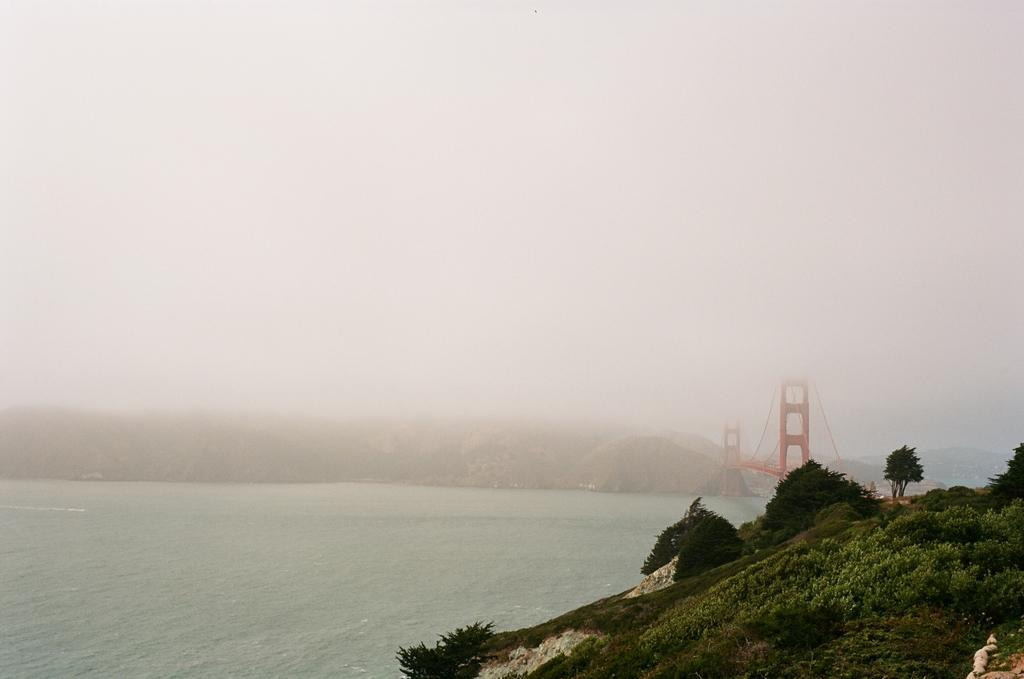What type of natural formation is visible in the image? There is a mountain in the image. What type of vegetation can be seen in the image? There are trees in the image. What structure is present in the image? There is a bridge in the image. What type of body of water is visible in the image? There is water in the image. What is visible at the top of the image? The sky is visible at the top of the image. Can you tell me how much salt is sprinkled on the yard in the image? There is no yard or salt present in the image. What type of wind instrument is being played by the person blowing in the image? There is no person blowing a wind instrument in the image. 